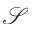<formula> <loc_0><loc_0><loc_500><loc_500>\mathcal { S }</formula> 